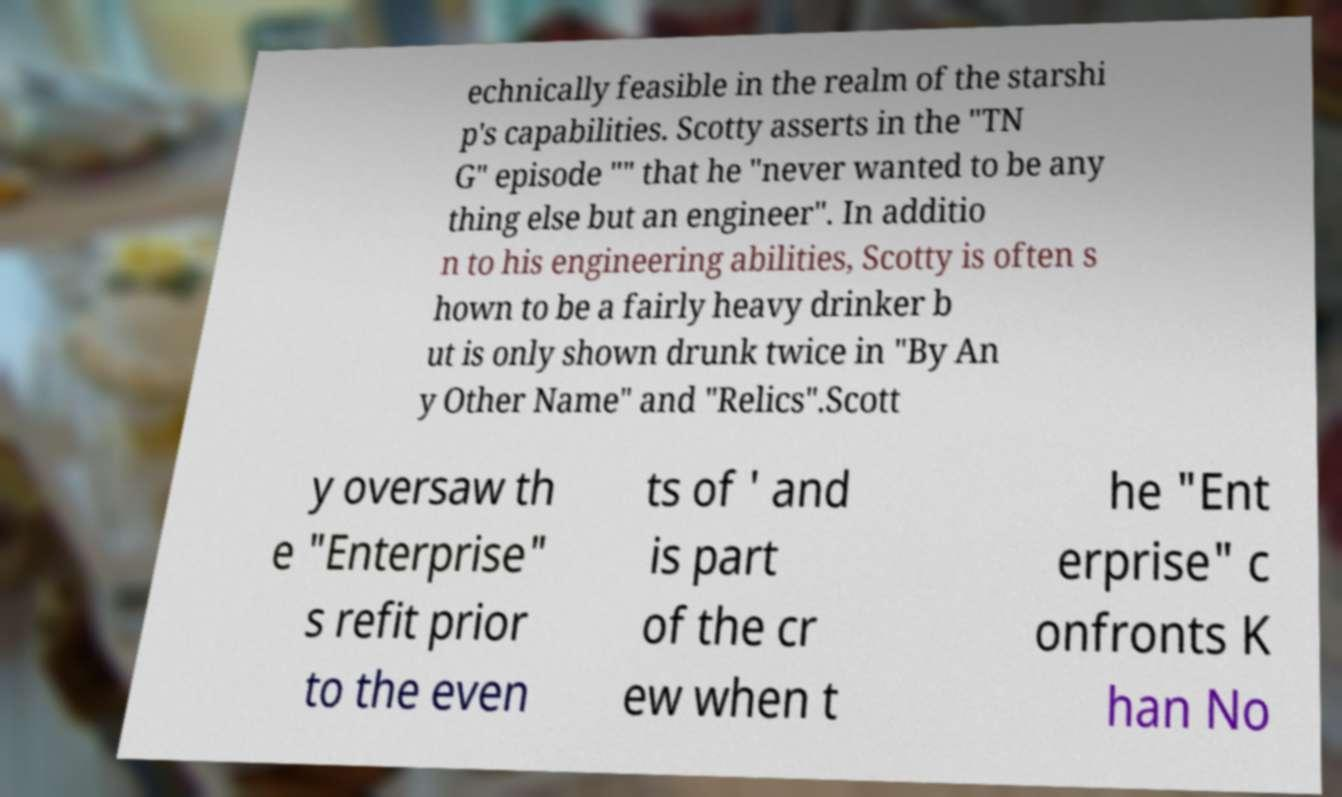There's text embedded in this image that I need extracted. Can you transcribe it verbatim? echnically feasible in the realm of the starshi p's capabilities. Scotty asserts in the "TN G" episode "" that he "never wanted to be any thing else but an engineer". In additio n to his engineering abilities, Scotty is often s hown to be a fairly heavy drinker b ut is only shown drunk twice in "By An y Other Name" and "Relics".Scott y oversaw th e "Enterprise" s refit prior to the even ts of ' and is part of the cr ew when t he "Ent erprise" c onfronts K han No 